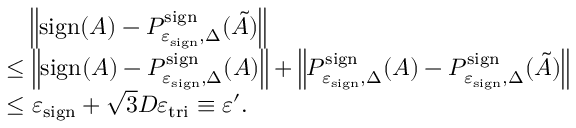Convert formula to latex. <formula><loc_0><loc_0><loc_500><loc_500>\begin{array} { r l } & { \quad \left \| s i g n ( A ) - P _ { \varepsilon _ { s i g n } , \Delta } ^ { s i g n } ( \tilde { A } ) \right \| } \\ & { \leq \left \| s i g n ( A ) - P _ { \varepsilon _ { s i g n } , \Delta } ^ { s i g n } ( A ) \right \| + \left \| P _ { \varepsilon _ { s i g n } , \Delta } ^ { s i g n } ( A ) - P _ { \varepsilon _ { s i g n } , \Delta } ^ { s i g n } ( \tilde { A } ) \right \| } \\ & { \leq \varepsilon _ { s i g n } + \sqrt { 3 } D \varepsilon _ { t r i } \equiv \varepsilon ^ { \prime } . } \end{array}</formula> 